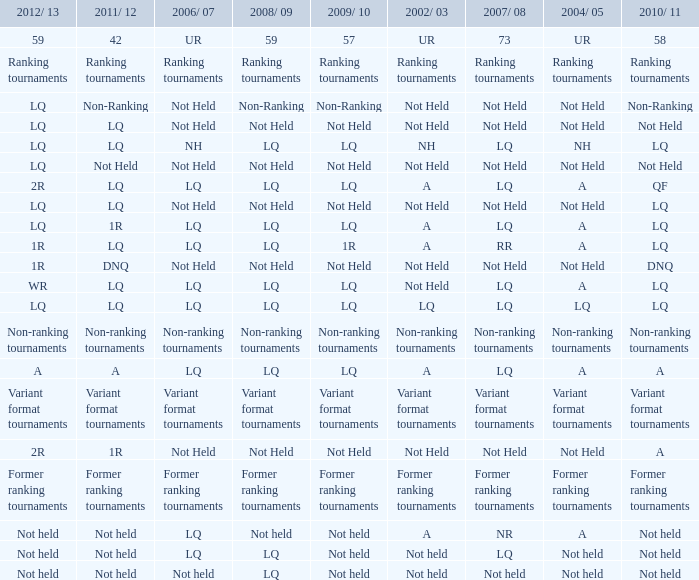Please provide the lq for 2006/07 and 2011/12, in addition to the lq for 2010/11 and 2002/03. LQ. 